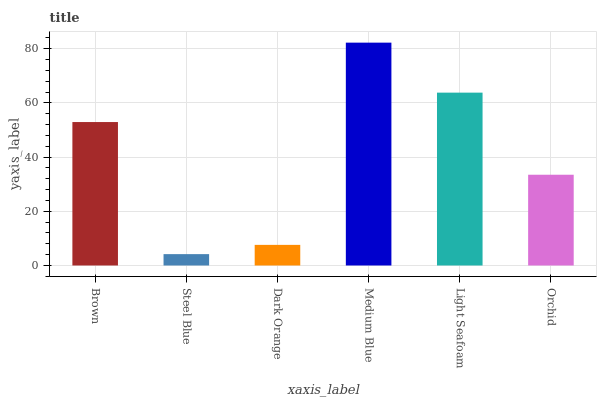Is Steel Blue the minimum?
Answer yes or no. Yes. Is Medium Blue the maximum?
Answer yes or no. Yes. Is Dark Orange the minimum?
Answer yes or no. No. Is Dark Orange the maximum?
Answer yes or no. No. Is Dark Orange greater than Steel Blue?
Answer yes or no. Yes. Is Steel Blue less than Dark Orange?
Answer yes or no. Yes. Is Steel Blue greater than Dark Orange?
Answer yes or no. No. Is Dark Orange less than Steel Blue?
Answer yes or no. No. Is Brown the high median?
Answer yes or no. Yes. Is Orchid the low median?
Answer yes or no. Yes. Is Medium Blue the high median?
Answer yes or no. No. Is Dark Orange the low median?
Answer yes or no. No. 